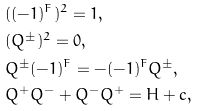Convert formula to latex. <formula><loc_0><loc_0><loc_500><loc_500>& ( ( - 1 ) ^ { F } ) ^ { 2 } = 1 , \\ & ( Q ^ { \pm } ) ^ { 2 } = 0 , \\ & Q ^ { \pm } ( - 1 ) ^ { F } = - ( - 1 ) ^ { F } Q ^ { \pm } , \\ & Q ^ { + } Q ^ { - } + Q ^ { - } Q ^ { + } = H + c ,</formula> 